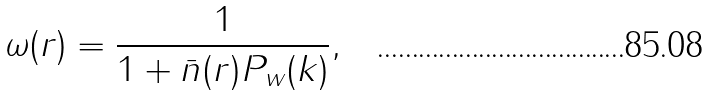Convert formula to latex. <formula><loc_0><loc_0><loc_500><loc_500>\omega ( r ) = \frac { 1 } { 1 + \bar { n } ( r ) P _ { w } ( k ) } ,</formula> 